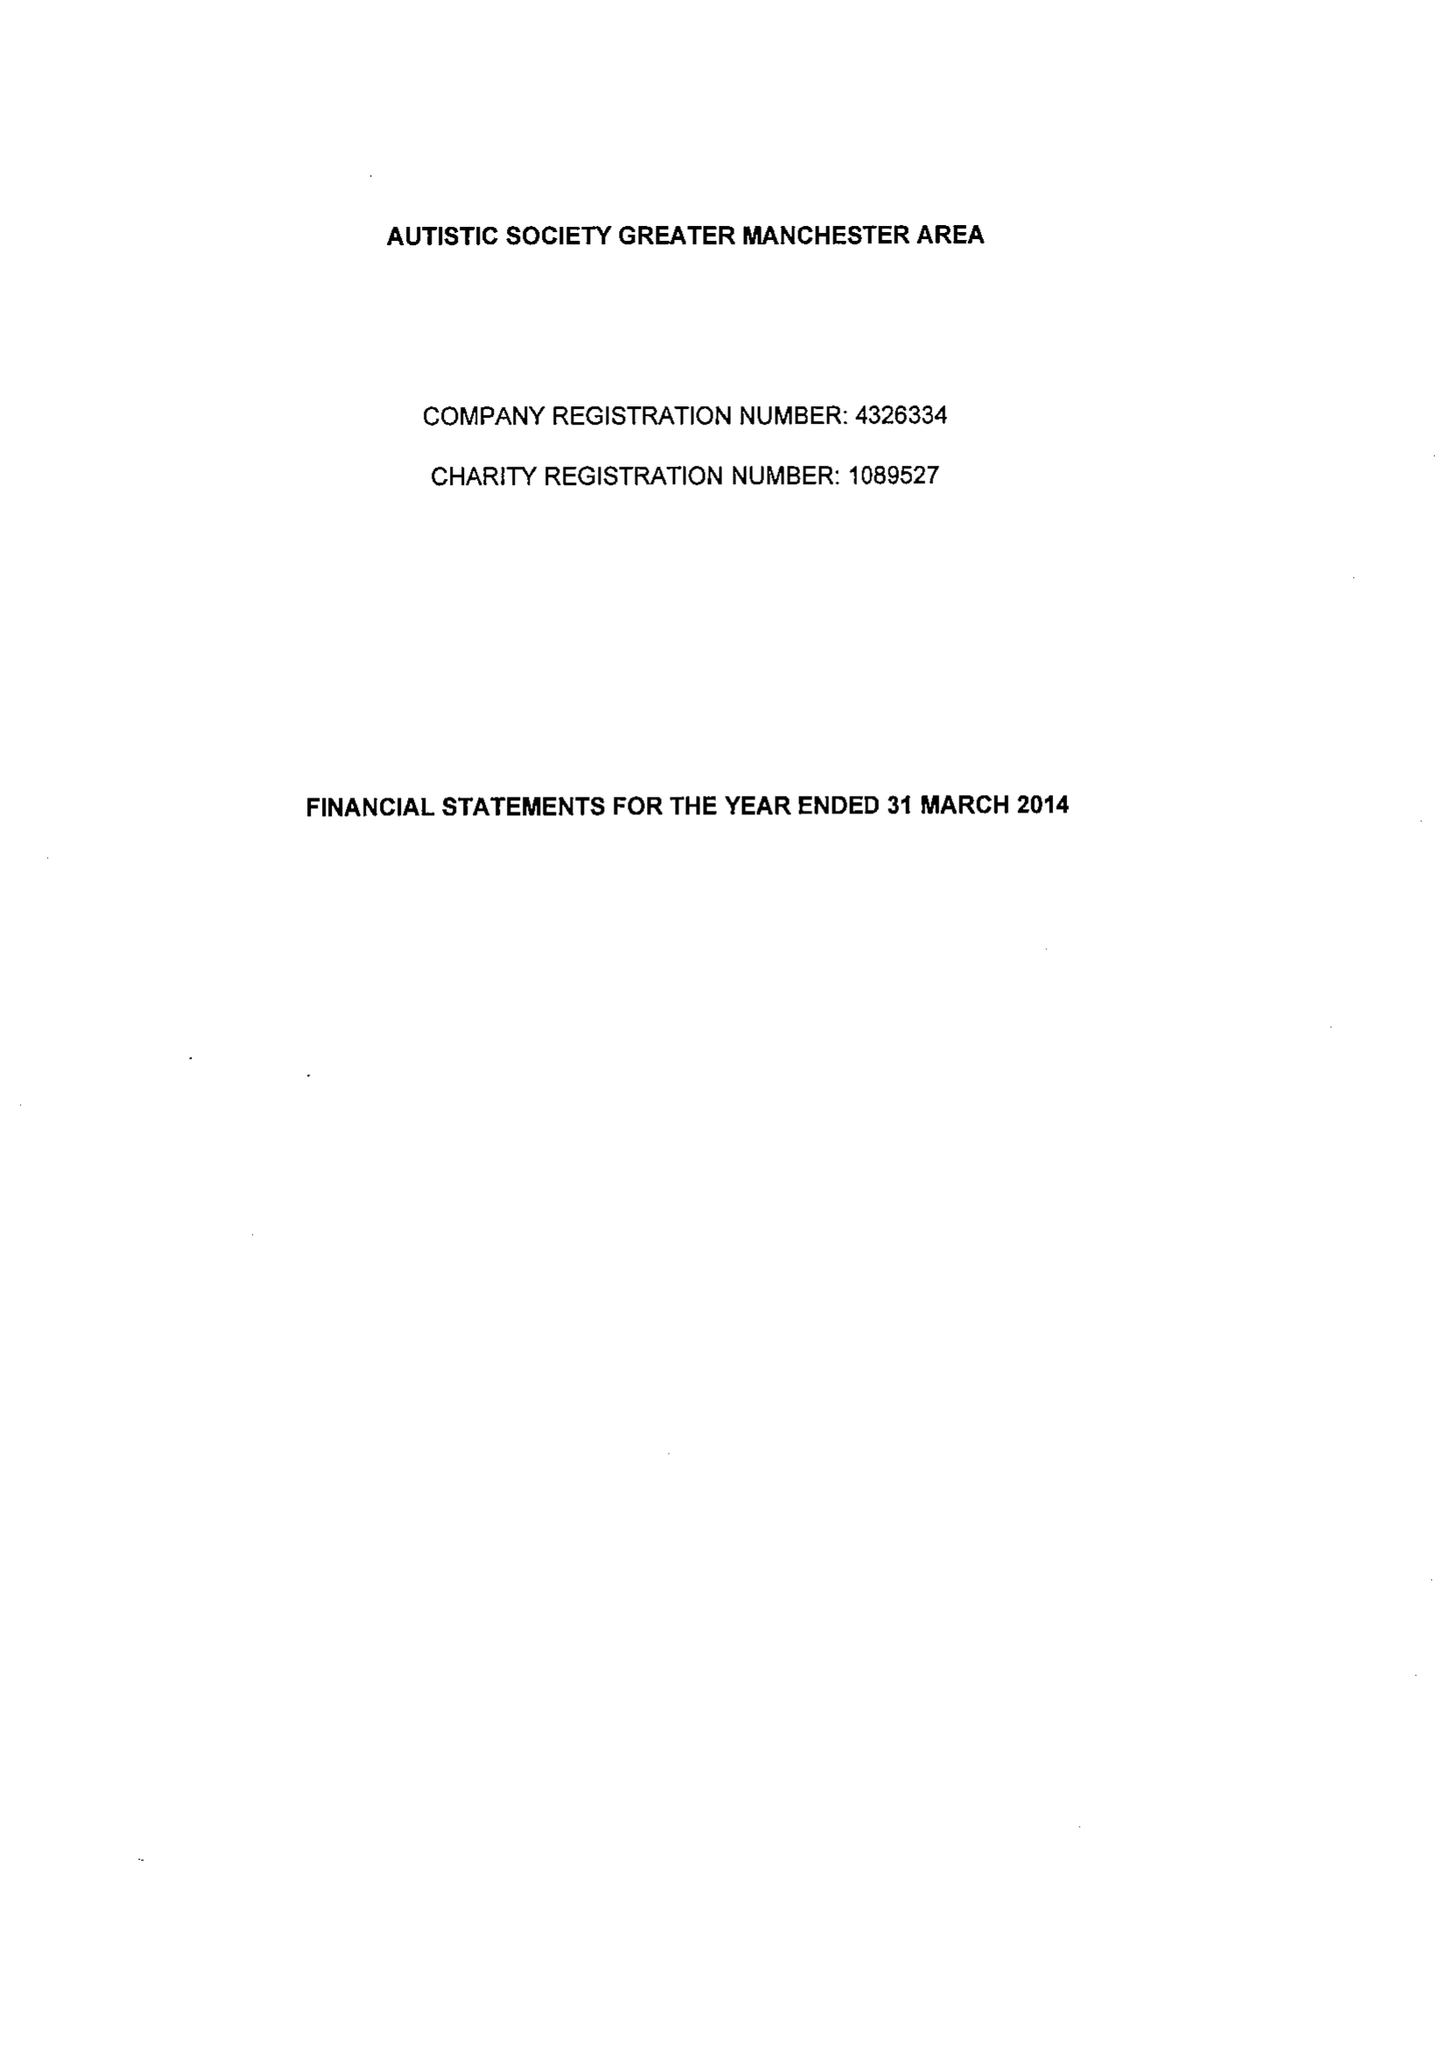What is the value for the spending_annually_in_british_pounds?
Answer the question using a single word or phrase. 359800.00 